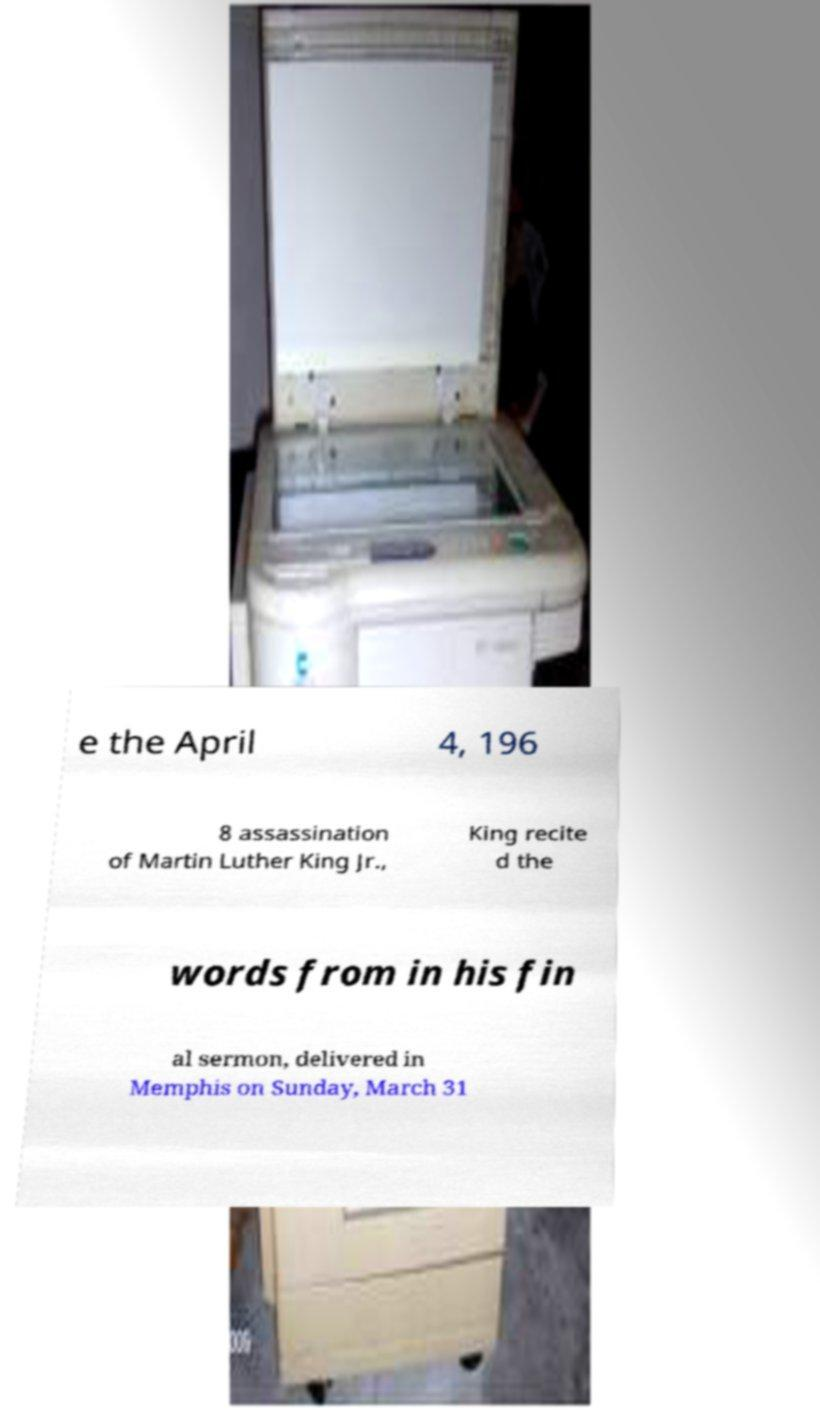Please read and relay the text visible in this image. What does it say? e the April 4, 196 8 assassination of Martin Luther King Jr., King recite d the words from in his fin al sermon, delivered in Memphis on Sunday, March 31 